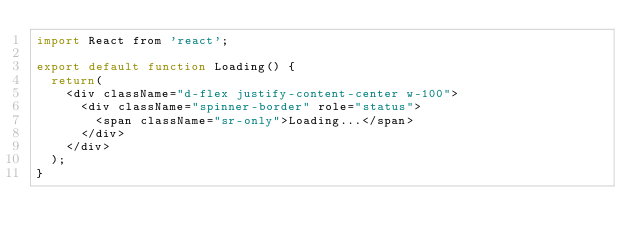Convert code to text. <code><loc_0><loc_0><loc_500><loc_500><_JavaScript_>import React from 'react';

export default function Loading() {
  return(
    <div className="d-flex justify-content-center w-100">
      <div className="spinner-border" role="status">
        <span className="sr-only">Loading...</span>
      </div>
    </div>
  );
}</code> 